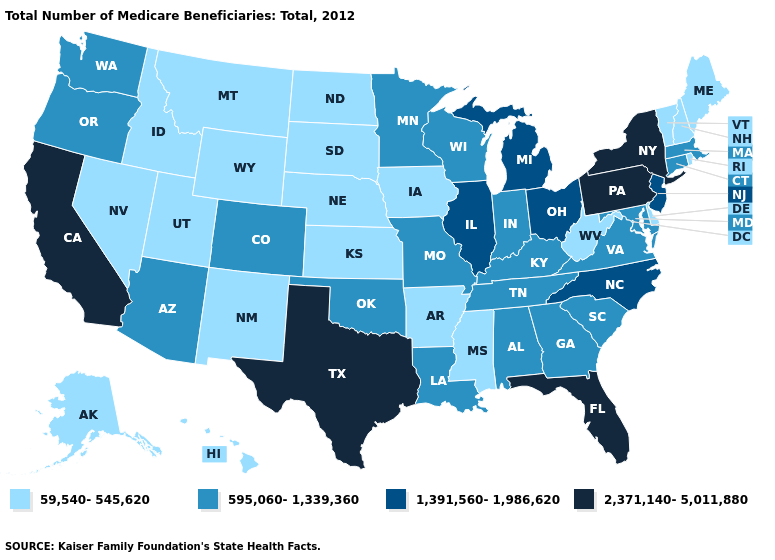Name the states that have a value in the range 595,060-1,339,360?
Concise answer only. Alabama, Arizona, Colorado, Connecticut, Georgia, Indiana, Kentucky, Louisiana, Maryland, Massachusetts, Minnesota, Missouri, Oklahoma, Oregon, South Carolina, Tennessee, Virginia, Washington, Wisconsin. Which states have the lowest value in the USA?
Answer briefly. Alaska, Arkansas, Delaware, Hawaii, Idaho, Iowa, Kansas, Maine, Mississippi, Montana, Nebraska, Nevada, New Hampshire, New Mexico, North Dakota, Rhode Island, South Dakota, Utah, Vermont, West Virginia, Wyoming. Name the states that have a value in the range 1,391,560-1,986,620?
Keep it brief. Illinois, Michigan, New Jersey, North Carolina, Ohio. What is the highest value in the South ?
Give a very brief answer. 2,371,140-5,011,880. What is the highest value in the USA?
Write a very short answer. 2,371,140-5,011,880. Does the first symbol in the legend represent the smallest category?
Write a very short answer. Yes. What is the highest value in the South ?
Concise answer only. 2,371,140-5,011,880. Which states have the highest value in the USA?
Be succinct. California, Florida, New York, Pennsylvania, Texas. Which states hav the highest value in the Northeast?
Quick response, please. New York, Pennsylvania. Among the states that border Mississippi , does Alabama have the highest value?
Concise answer only. Yes. Name the states that have a value in the range 2,371,140-5,011,880?
Answer briefly. California, Florida, New York, Pennsylvania, Texas. Among the states that border Georgia , which have the lowest value?
Keep it brief. Alabama, South Carolina, Tennessee. Is the legend a continuous bar?
Give a very brief answer. No. Name the states that have a value in the range 1,391,560-1,986,620?
Keep it brief. Illinois, Michigan, New Jersey, North Carolina, Ohio. 